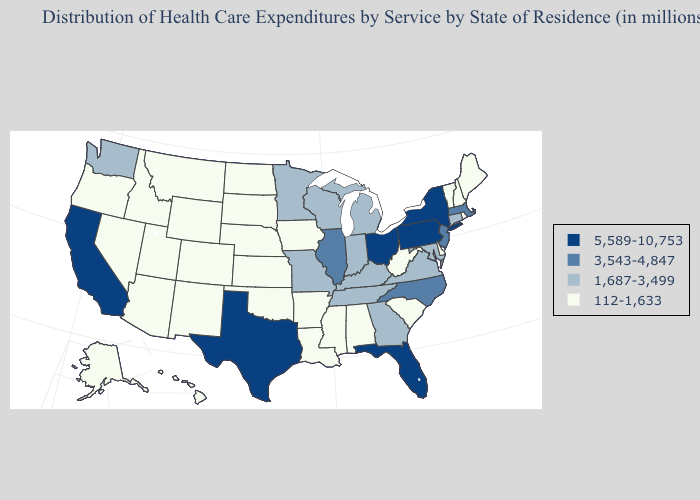What is the lowest value in states that border Ohio?
Short answer required. 112-1,633. Does New Hampshire have the highest value in the Northeast?
Concise answer only. No. Does Kentucky have the lowest value in the USA?
Keep it brief. No. Among the states that border Indiana , does Illinois have the highest value?
Be succinct. No. Name the states that have a value in the range 1,687-3,499?
Write a very short answer. Connecticut, Georgia, Indiana, Kentucky, Maryland, Michigan, Minnesota, Missouri, Tennessee, Virginia, Washington, Wisconsin. Name the states that have a value in the range 5,589-10,753?
Quick response, please. California, Florida, New York, Ohio, Pennsylvania, Texas. Among the states that border Oklahoma , which have the lowest value?
Give a very brief answer. Arkansas, Colorado, Kansas, New Mexico. Which states hav the highest value in the South?
Concise answer only. Florida, Texas. What is the lowest value in the USA?
Write a very short answer. 112-1,633. Does Nebraska have a lower value than Washington?
Concise answer only. Yes. Name the states that have a value in the range 3,543-4,847?
Short answer required. Illinois, Massachusetts, New Jersey, North Carolina. What is the value of Rhode Island?
Quick response, please. 112-1,633. What is the value of Nebraska?
Keep it brief. 112-1,633. What is the value of Connecticut?
Write a very short answer. 1,687-3,499. What is the highest value in the West ?
Answer briefly. 5,589-10,753. 